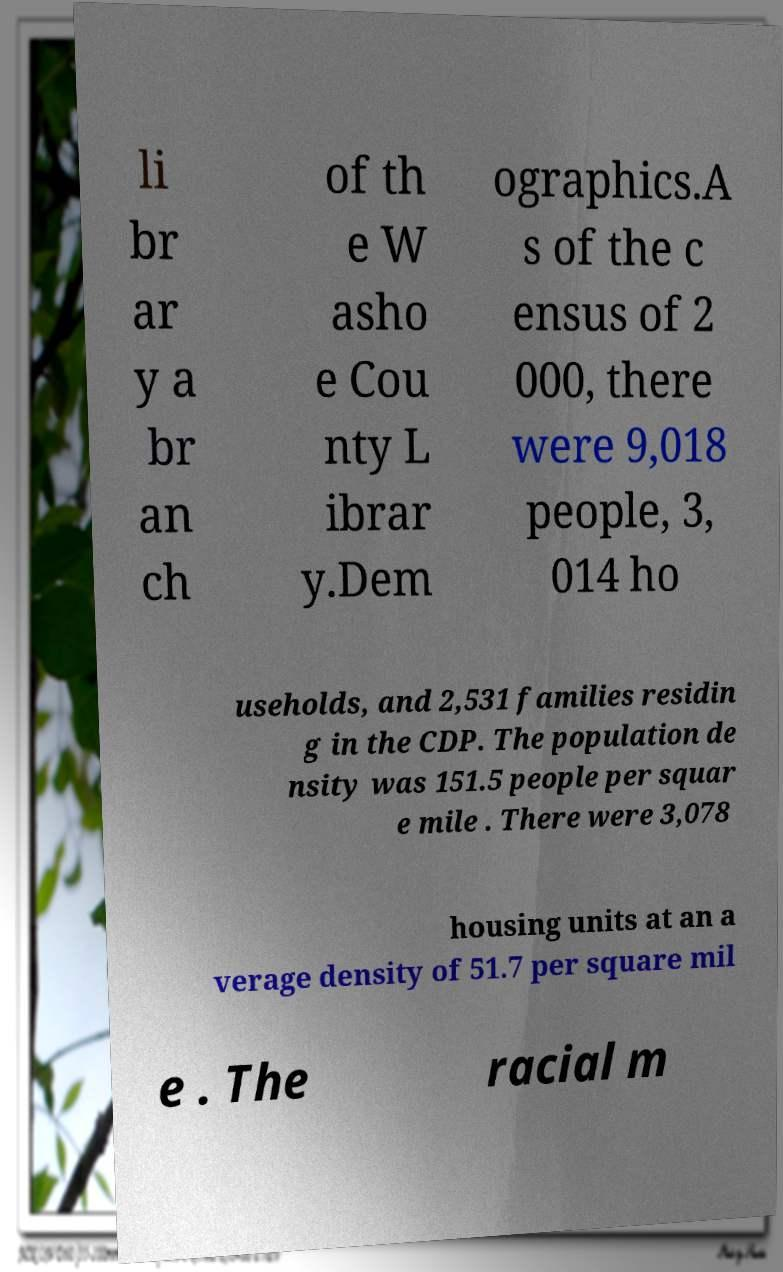Please read and relay the text visible in this image. What does it say? li br ar y a br an ch of th e W asho e Cou nty L ibrar y.Dem ographics.A s of the c ensus of 2 000, there were 9,018 people, 3, 014 ho useholds, and 2,531 families residin g in the CDP. The population de nsity was 151.5 people per squar e mile . There were 3,078 housing units at an a verage density of 51.7 per square mil e . The racial m 